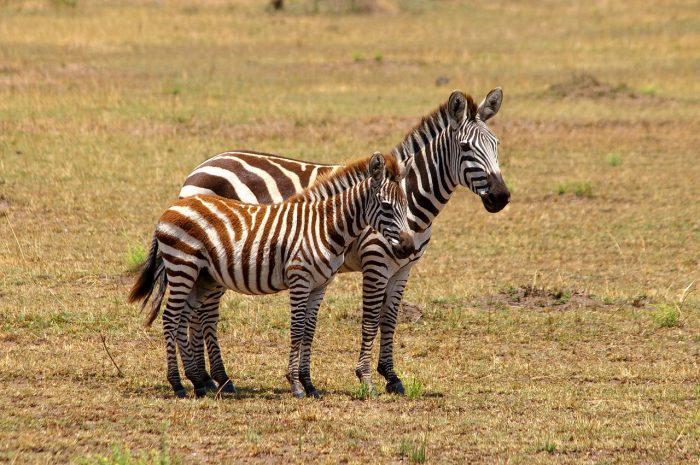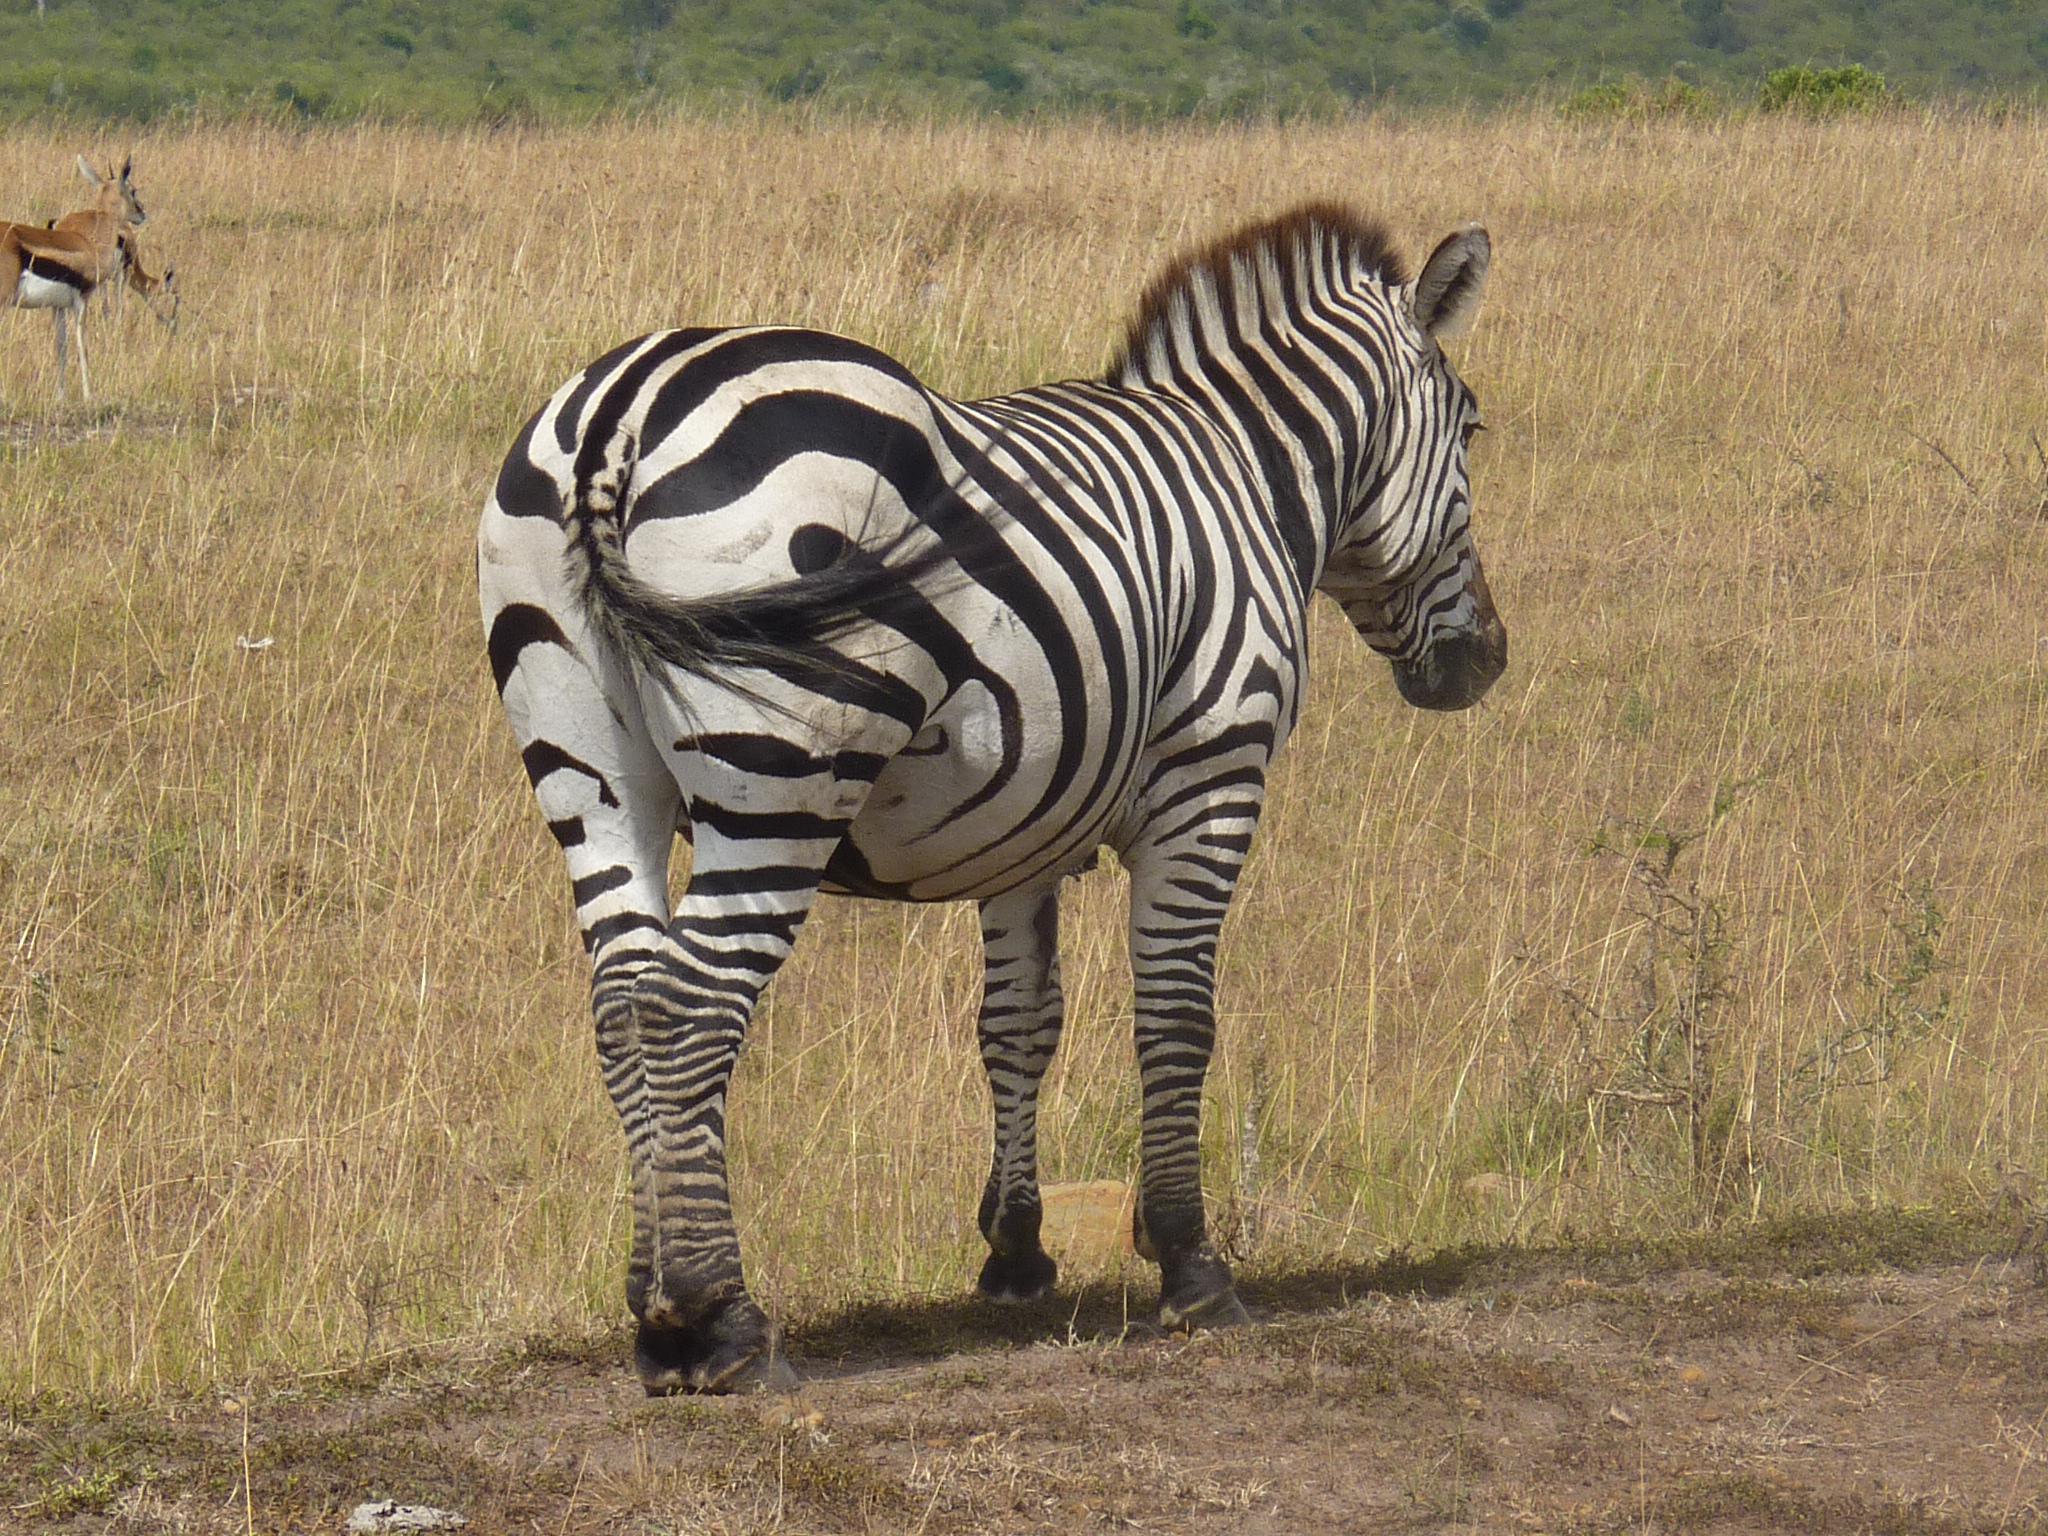The first image is the image on the left, the second image is the image on the right. For the images displayed, is the sentence "There are two zebras in the left image." factually correct? Answer yes or no. Yes. The first image is the image on the left, the second image is the image on the right. Evaluate the accuracy of this statement regarding the images: "One of the images shows exactly one zebra, while the other image shows exactly two which have a brown tint to their coloring.". Is it true? Answer yes or no. Yes. 